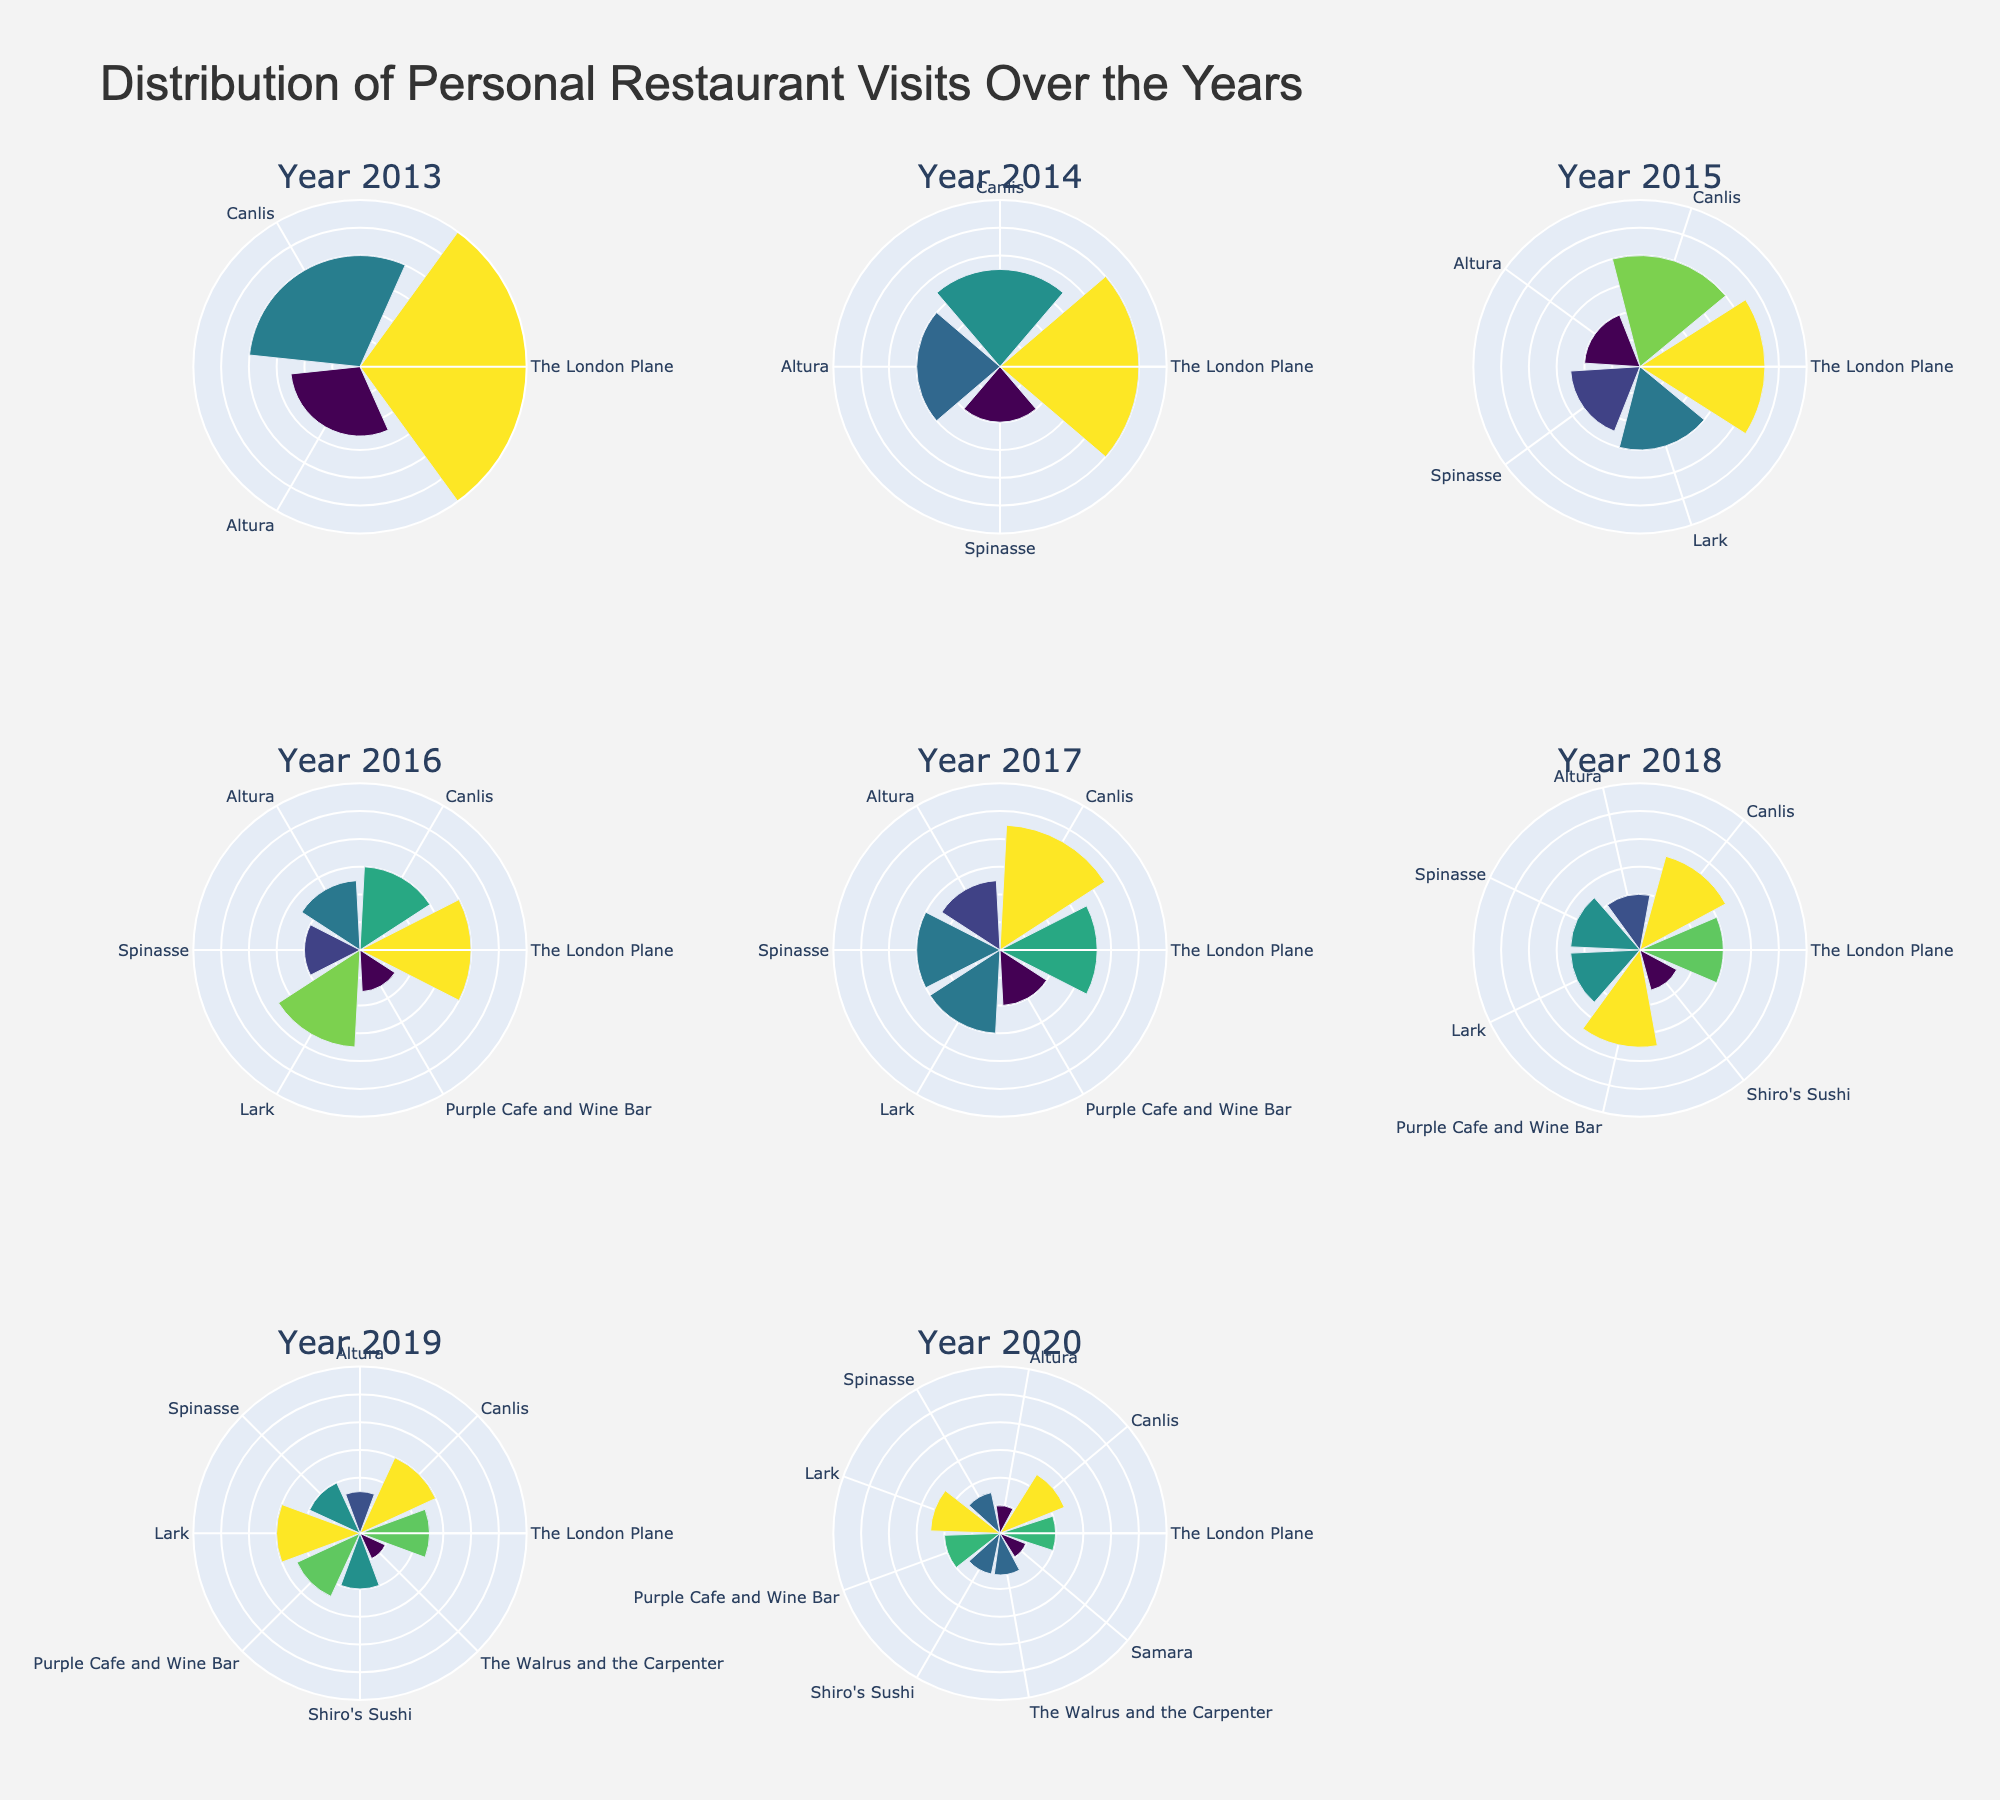How many total years are displayed in the figure? Count the number of subplot titles, each representing a year. There are eight years from 2013 to 2020.
Answer: 8 Which restaurant had the highest number of visits in any given year? Look at the maximum value across all subplots for any restaurant. The London Plane had 12 visits in 2013.
Answer: The London Plane What is the average number of visits to Canlis per year? Sum the number of visits to Canlis for each year and divide by the total number of years. (8 + 7 + 8 + 6 + 9 + 7 + 6 + 5) / 8 = 56 / 8 = 7
Answer: 7 In which year did The London Plane have its lowest number of visits, and how many visits were there? Find the subplot for each year and look for The London Plane's visits. The lowest value is in 2020 with 4 visits.
Answer: 2020, 4 How did the visits to Spinasse change from 2014 to 2015? Compare the visits from the 2014 subplot to the 2015 subplot for Spinasse. The visits increased from 4 to 5.
Answer: Increased by 1 Which year had the most diverse set of restaurants visited? Look at each subplot and count the number of unique restaurant names. 2019 has the most unique restaurants with 8.
Answer: 2019 Compare the total visits across all restaurants between 2013 and 2020. Which year had the highest total visits? Sum the visits for each restaurant by year and compare. 2013 has a total of 25 visits, 2014 has 27, 2015 has 32, 2016 has 33, 2017 has 37, 2018 has 37, 2019 has 35, and 2020 has 28.
Answer: 2017 and 2018 Did Altura ever have the highest number of visits among all restaurants in any year? Check each year's subplot to see if Altura's visits were higher than the other restaurants in that subplot. No, Altura never had the highest number of visits.
Answer: No Between 2019 and 2020, how did the visits to The Walrus and the Carpenter change? Look at the visits in 2019 and 2020 subplots for The Walrus and the Carpenter. The visits increased from 2 in 2019 to 3 in 2020.
Answer: Increased by 1 Which restaurant shows a consistent decrease in visits over the years? Compare the visits year by year for each restaurant and find the one with consistently decreasing visits. The London Plane shows a consistent decrease.
Answer: The London Plane 